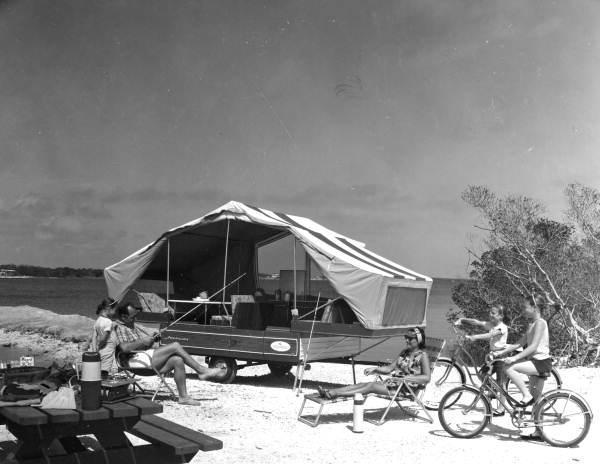How many people are in this photo?
Give a very brief answer. 5. How many bicycles can you see?
Give a very brief answer. 2. How many people are there?
Give a very brief answer. 3. How many dining tables are in the photo?
Give a very brief answer. 1. 